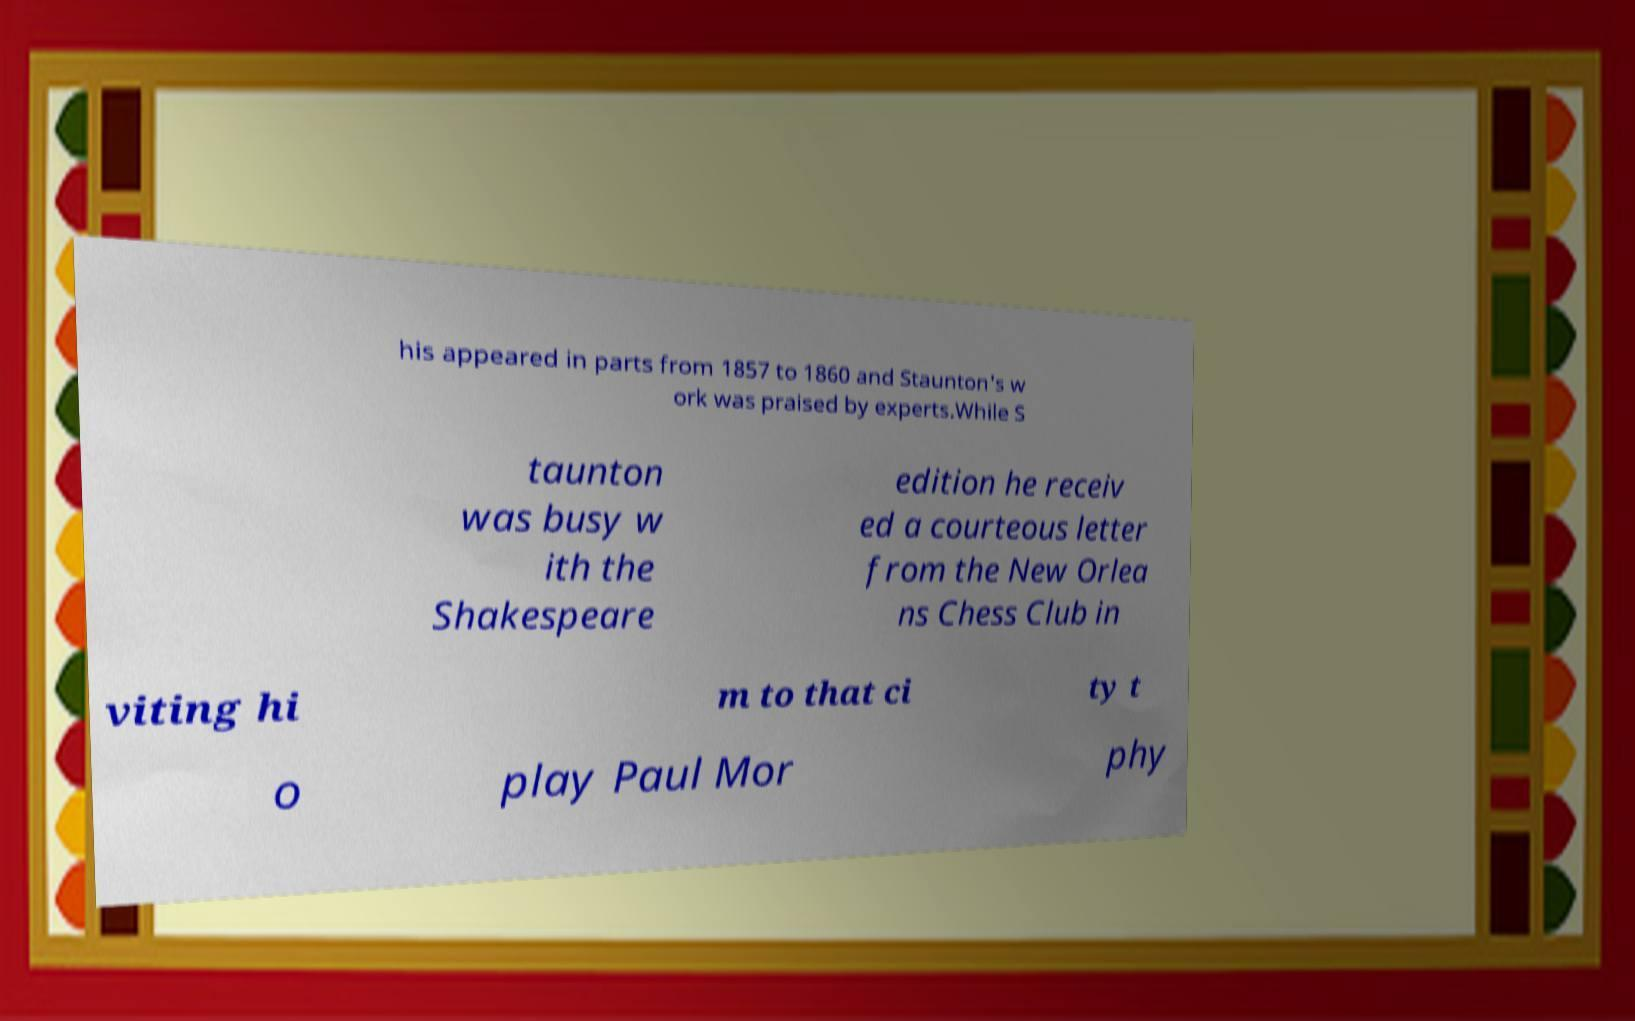Please read and relay the text visible in this image. What does it say? his appeared in parts from 1857 to 1860 and Staunton's w ork was praised by experts.While S taunton was busy w ith the Shakespeare edition he receiv ed a courteous letter from the New Orlea ns Chess Club in viting hi m to that ci ty t o play Paul Mor phy 